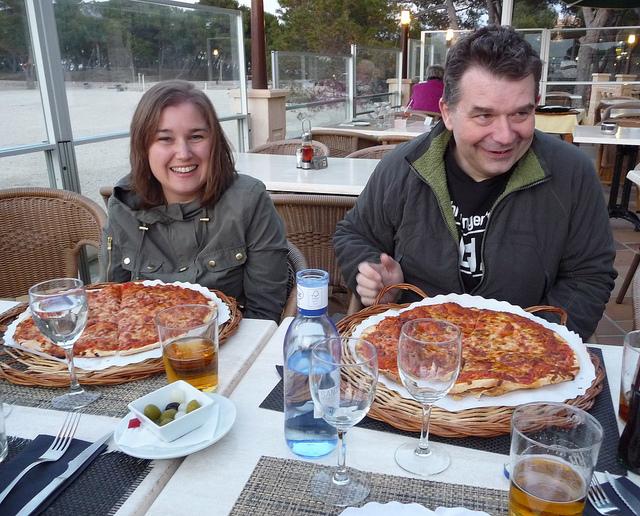Which person is taller?
Keep it brief. Man. Are they drinking alcohol?
Keep it brief. Yes. Wouldn't one pizza have been enough for both of them?
Answer briefly. Yes. 